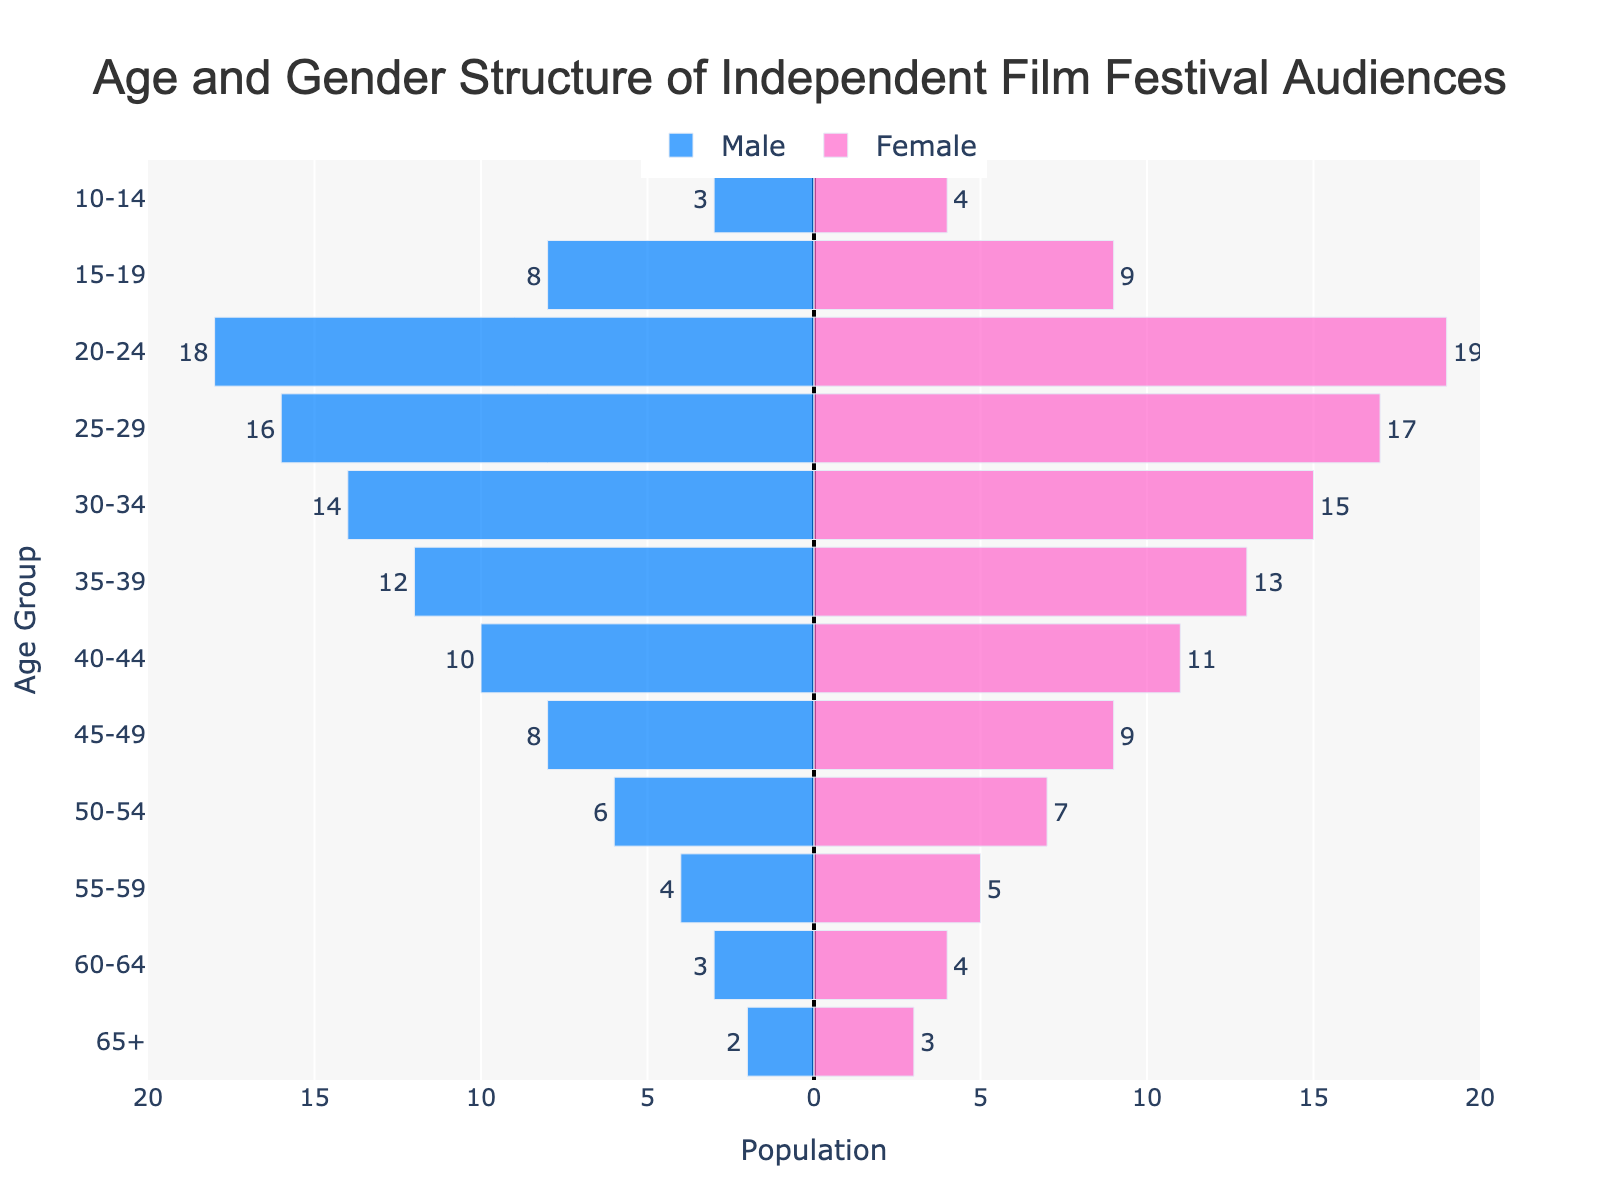What is the title of the plot? The title is located at the top of the figure and provides a succinct description of the data visualized. It reads "Age and Gender Structure of Independent Film Festival Audiences."
Answer: Age and Gender Structure of Independent Film Festival Audiences Which age group has the highest number of female attendees? By examining the height of the bars on the right side (representing females), the age group 20-24 has the highest value, reflected by the 19 units.
Answer: 20-24 How does the number of male attendees in the 30-34 age group compare to the number of female attendees in the same group? The male attendance for 30-34 is 14, and the female attendance is 15. Since 14 is less than 15, we can conclude there are fewer males than females in the 30-34 age group.
Answer: Fewer males What is the total number of male and female attendees in the 40-44 age group? For the 40-44 age group, there are 10 males and 11 females. Adding them gives us 10 + 11 = 21.
Answer: 21 Which age group has the lowest number of attendees when combining both males and females? The age group 10-14 has 3 males and 4 females. Combining both gives us 3 + 4 = 7. Checking other age groups results in higher values, so 10-14 has the lowest.
Answer: 10-14 What is the proportion of female to male attendees in the 25-29 age group? The number of female attendees in the 25-29 age group is 17, and for males, it is 16. The proportion is calculated as 17/16, approximately 1.06.
Answer: Approximately 1.06 What is the total number of attendees in the 55-59 age group for both genders combined? The number of male attendees is 4, and the number of female attendees is 5 in the 55-59 age group. Summing these up gives us 4 + 5 = 9.
Answer: 9 Between the 45-49 and 50-54 age groups, which has more female attendees? For the 45-49 age group, there are 9 females. For the 50-54 age group, there are 7 females. Comparing 9 and 7, it is clear that the 45-49 age group has more female attendees.
Answer: 45-49 What is the sum of male attendees for the age groups 15-19, 10-14, and 55-59? The number of male attendees for 15-19 is 8, for 10-14 it is 3, and for 55-59 it is 4. Summing these up gives us 8 + 3 + 4 = 15.
Answer: 15 